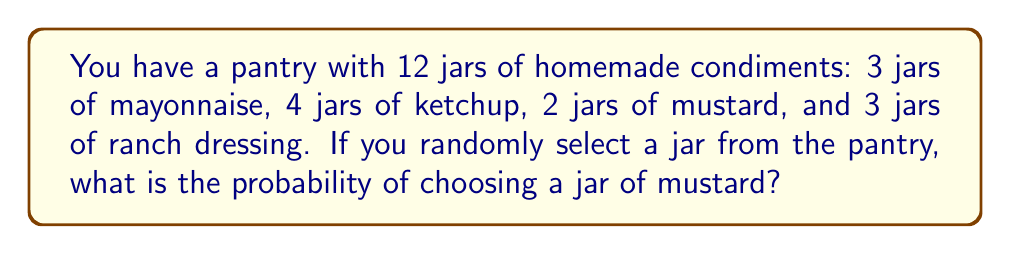Can you answer this question? To solve this problem, we'll use the concept of probability in a finite sample space.

Step 1: Determine the total number of jars (sample space).
Total jars = 3 + 4 + 2 + 3 = 12

Step 2: Identify the number of favorable outcomes (jars of mustard).
Number of mustard jars = 2

Step 3: Calculate the probability using the formula:
$$P(\text{event}) = \frac{\text{number of favorable outcomes}}{\text{total number of possible outcomes}}$$

In this case:
$$P(\text{selecting mustard}) = \frac{\text{number of mustard jars}}{\text{total number of jars}} = \frac{2}{12}$$

Step 4: Simplify the fraction:
$$\frac{2}{12} = \frac{1}{6}$$

Therefore, the probability of randomly selecting a jar of mustard is $\frac{1}{6}$ or approximately 0.1667 (16.67%).
Answer: $\frac{1}{6}$ 